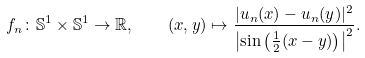Convert formula to latex. <formula><loc_0><loc_0><loc_500><loc_500>f _ { n } \colon \mathbb { S } ^ { 1 } \times \mathbb { S } ^ { 1 } \to \mathbb { R } , \quad ( x , y ) \mapsto \frac { | u _ { n } ( x ) - u _ { n } ( y ) | ^ { 2 } } { \left | \sin \left ( \frac { 1 } { 2 } ( x - y ) \right ) \right | ^ { 2 } } .</formula> 